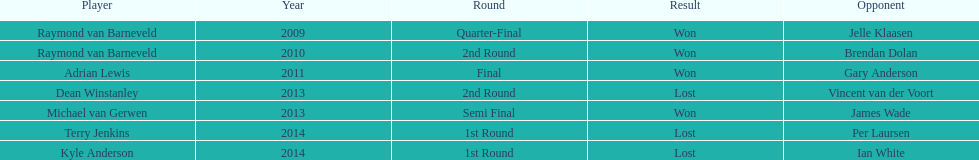Would you be able to parse every entry in this table? {'header': ['Player', 'Year', 'Round', 'Result', 'Opponent'], 'rows': [['Raymond van Barneveld', '2009', 'Quarter-Final', 'Won', 'Jelle Klaasen'], ['Raymond van Barneveld', '2010', '2nd Round', 'Won', 'Brendan Dolan'], ['Adrian Lewis', '2011', 'Final', 'Won', 'Gary Anderson'], ['Dean Winstanley', '2013', '2nd Round', 'Lost', 'Vincent van der Voort'], ['Michael van Gerwen', '2013', 'Semi Final', 'Won', 'James Wade'], ['Terry Jenkins', '2014', '1st Round', 'Lost', 'Per Laursen'], ['Kyle Anderson', '2014', '1st Round', 'Lost', 'Ian White']]} Who secured the latest victory against their adversary? Michael van Gerwen. 